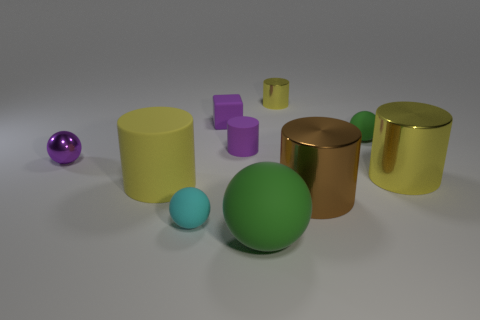Subtract all yellow cylinders. How many were subtracted if there are1yellow cylinders left? 2 Subtract all brown blocks. How many yellow cylinders are left? 3 Subtract all brown cylinders. How many cylinders are left? 4 Subtract all small purple cylinders. How many cylinders are left? 4 Subtract all cyan cylinders. Subtract all green spheres. How many cylinders are left? 5 Subtract all balls. How many objects are left? 6 Add 3 large purple metal cubes. How many large purple metal cubes exist? 3 Subtract 0 red cubes. How many objects are left? 10 Subtract all big brown metallic cylinders. Subtract all tiny cylinders. How many objects are left? 7 Add 7 brown metallic cylinders. How many brown metallic cylinders are left? 8 